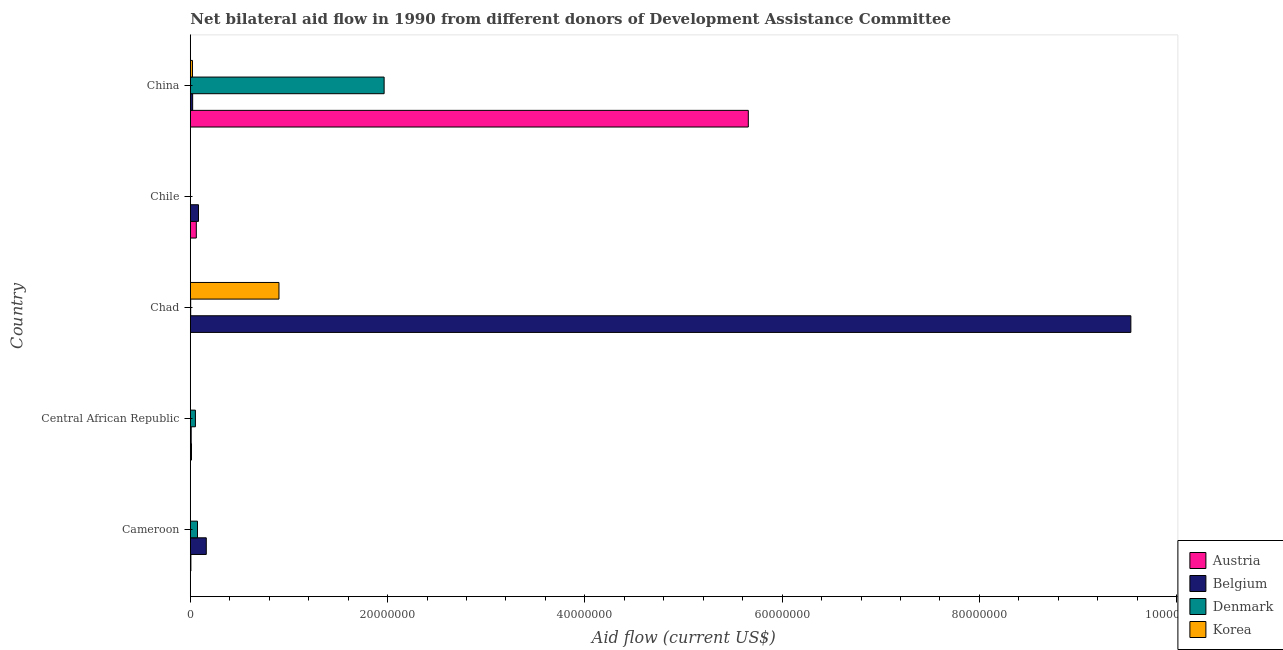How many different coloured bars are there?
Provide a short and direct response. 4. Are the number of bars per tick equal to the number of legend labels?
Keep it short and to the point. No. Are the number of bars on each tick of the Y-axis equal?
Your answer should be compact. No. How many bars are there on the 4th tick from the bottom?
Offer a very short reply. 3. What is the amount of aid given by denmark in Chile?
Your response must be concise. 0. Across all countries, what is the maximum amount of aid given by austria?
Your response must be concise. 5.66e+07. What is the total amount of aid given by korea in the graph?
Offer a very short reply. 9.26e+06. What is the difference between the amount of aid given by korea in Cameroon and that in China?
Offer a terse response. -2.00e+05. What is the difference between the amount of aid given by denmark in Central African Republic and the amount of aid given by korea in Chile?
Your answer should be compact. 5.10e+05. What is the average amount of aid given by denmark per country?
Your response must be concise. 4.19e+06. What is the difference between the amount of aid given by austria and amount of aid given by belgium in Central African Republic?
Ensure brevity in your answer.  3.00e+04. What is the ratio of the amount of aid given by korea in Cameroon to that in Chile?
Offer a terse response. 2. What is the difference between the highest and the second highest amount of aid given by korea?
Offer a terse response. 8.77e+06. What is the difference between the highest and the lowest amount of aid given by austria?
Your answer should be compact. 5.66e+07. How many bars are there?
Your response must be concise. 19. Are all the bars in the graph horizontal?
Provide a succinct answer. Yes. Are the values on the major ticks of X-axis written in scientific E-notation?
Your answer should be very brief. No. Does the graph contain any zero values?
Your answer should be compact. Yes. Does the graph contain grids?
Make the answer very short. No. What is the title of the graph?
Keep it short and to the point. Net bilateral aid flow in 1990 from different donors of Development Assistance Committee. Does "European Union" appear as one of the legend labels in the graph?
Your answer should be compact. No. What is the Aid flow (current US$) of Belgium in Cameroon?
Ensure brevity in your answer.  1.62e+06. What is the Aid flow (current US$) in Denmark in Cameroon?
Give a very brief answer. 7.30e+05. What is the Aid flow (current US$) of Korea in Cameroon?
Offer a very short reply. 2.00e+04. What is the Aid flow (current US$) in Denmark in Central African Republic?
Provide a succinct answer. 5.20e+05. What is the Aid flow (current US$) of Korea in Central African Republic?
Give a very brief answer. 2.00e+04. What is the Aid flow (current US$) of Austria in Chad?
Offer a very short reply. 10000. What is the Aid flow (current US$) in Belgium in Chad?
Your response must be concise. 9.54e+07. What is the Aid flow (current US$) in Korea in Chad?
Provide a short and direct response. 8.99e+06. What is the Aid flow (current US$) in Belgium in Chile?
Provide a short and direct response. 8.30e+05. What is the Aid flow (current US$) of Austria in China?
Keep it short and to the point. 5.66e+07. What is the Aid flow (current US$) of Denmark in China?
Your response must be concise. 1.96e+07. What is the Aid flow (current US$) of Korea in China?
Offer a very short reply. 2.20e+05. Across all countries, what is the maximum Aid flow (current US$) of Austria?
Offer a terse response. 5.66e+07. Across all countries, what is the maximum Aid flow (current US$) in Belgium?
Ensure brevity in your answer.  9.54e+07. Across all countries, what is the maximum Aid flow (current US$) in Denmark?
Provide a succinct answer. 1.96e+07. Across all countries, what is the maximum Aid flow (current US$) in Korea?
Your answer should be compact. 8.99e+06. Across all countries, what is the minimum Aid flow (current US$) of Austria?
Provide a short and direct response. 10000. Across all countries, what is the minimum Aid flow (current US$) in Belgium?
Ensure brevity in your answer.  9.00e+04. Across all countries, what is the minimum Aid flow (current US$) of Denmark?
Your answer should be very brief. 0. Across all countries, what is the minimum Aid flow (current US$) in Korea?
Ensure brevity in your answer.  10000. What is the total Aid flow (current US$) in Austria in the graph?
Provide a succinct answer. 5.74e+07. What is the total Aid flow (current US$) of Belgium in the graph?
Your response must be concise. 9.81e+07. What is the total Aid flow (current US$) of Denmark in the graph?
Your response must be concise. 2.09e+07. What is the total Aid flow (current US$) in Korea in the graph?
Keep it short and to the point. 9.26e+06. What is the difference between the Aid flow (current US$) of Belgium in Cameroon and that in Central African Republic?
Your answer should be compact. 1.53e+06. What is the difference between the Aid flow (current US$) of Belgium in Cameroon and that in Chad?
Provide a short and direct response. -9.37e+07. What is the difference between the Aid flow (current US$) in Denmark in Cameroon and that in Chad?
Provide a short and direct response. 6.90e+05. What is the difference between the Aid flow (current US$) in Korea in Cameroon and that in Chad?
Provide a succinct answer. -8.97e+06. What is the difference between the Aid flow (current US$) in Austria in Cameroon and that in Chile?
Your response must be concise. -5.50e+05. What is the difference between the Aid flow (current US$) in Belgium in Cameroon and that in Chile?
Make the answer very short. 7.90e+05. What is the difference between the Aid flow (current US$) in Korea in Cameroon and that in Chile?
Offer a terse response. 10000. What is the difference between the Aid flow (current US$) in Austria in Cameroon and that in China?
Provide a succinct answer. -5.65e+07. What is the difference between the Aid flow (current US$) of Belgium in Cameroon and that in China?
Make the answer very short. 1.38e+06. What is the difference between the Aid flow (current US$) in Denmark in Cameroon and that in China?
Keep it short and to the point. -1.89e+07. What is the difference between the Aid flow (current US$) in Korea in Cameroon and that in China?
Your answer should be very brief. -2.00e+05. What is the difference between the Aid flow (current US$) of Austria in Central African Republic and that in Chad?
Offer a very short reply. 1.10e+05. What is the difference between the Aid flow (current US$) in Belgium in Central African Republic and that in Chad?
Offer a terse response. -9.53e+07. What is the difference between the Aid flow (current US$) of Korea in Central African Republic and that in Chad?
Provide a succinct answer. -8.97e+06. What is the difference between the Aid flow (current US$) of Austria in Central African Republic and that in Chile?
Offer a terse response. -4.90e+05. What is the difference between the Aid flow (current US$) in Belgium in Central African Republic and that in Chile?
Keep it short and to the point. -7.40e+05. What is the difference between the Aid flow (current US$) of Korea in Central African Republic and that in Chile?
Offer a very short reply. 10000. What is the difference between the Aid flow (current US$) in Austria in Central African Republic and that in China?
Offer a very short reply. -5.64e+07. What is the difference between the Aid flow (current US$) of Belgium in Central African Republic and that in China?
Your answer should be compact. -1.50e+05. What is the difference between the Aid flow (current US$) of Denmark in Central African Republic and that in China?
Offer a very short reply. -1.91e+07. What is the difference between the Aid flow (current US$) in Korea in Central African Republic and that in China?
Offer a terse response. -2.00e+05. What is the difference between the Aid flow (current US$) in Austria in Chad and that in Chile?
Your response must be concise. -6.00e+05. What is the difference between the Aid flow (current US$) in Belgium in Chad and that in Chile?
Keep it short and to the point. 9.45e+07. What is the difference between the Aid flow (current US$) in Korea in Chad and that in Chile?
Provide a succinct answer. 8.98e+06. What is the difference between the Aid flow (current US$) of Austria in Chad and that in China?
Give a very brief answer. -5.66e+07. What is the difference between the Aid flow (current US$) in Belgium in Chad and that in China?
Offer a very short reply. 9.51e+07. What is the difference between the Aid flow (current US$) in Denmark in Chad and that in China?
Your response must be concise. -1.96e+07. What is the difference between the Aid flow (current US$) of Korea in Chad and that in China?
Ensure brevity in your answer.  8.77e+06. What is the difference between the Aid flow (current US$) of Austria in Chile and that in China?
Provide a short and direct response. -5.60e+07. What is the difference between the Aid flow (current US$) of Belgium in Chile and that in China?
Provide a succinct answer. 5.90e+05. What is the difference between the Aid flow (current US$) in Korea in Chile and that in China?
Your answer should be compact. -2.10e+05. What is the difference between the Aid flow (current US$) of Austria in Cameroon and the Aid flow (current US$) of Belgium in Central African Republic?
Offer a terse response. -3.00e+04. What is the difference between the Aid flow (current US$) of Austria in Cameroon and the Aid flow (current US$) of Denmark in Central African Republic?
Provide a short and direct response. -4.60e+05. What is the difference between the Aid flow (current US$) in Austria in Cameroon and the Aid flow (current US$) in Korea in Central African Republic?
Ensure brevity in your answer.  4.00e+04. What is the difference between the Aid flow (current US$) in Belgium in Cameroon and the Aid flow (current US$) in Denmark in Central African Republic?
Your answer should be compact. 1.10e+06. What is the difference between the Aid flow (current US$) of Belgium in Cameroon and the Aid flow (current US$) of Korea in Central African Republic?
Provide a short and direct response. 1.60e+06. What is the difference between the Aid flow (current US$) in Denmark in Cameroon and the Aid flow (current US$) in Korea in Central African Republic?
Your answer should be compact. 7.10e+05. What is the difference between the Aid flow (current US$) in Austria in Cameroon and the Aid flow (current US$) in Belgium in Chad?
Offer a terse response. -9.53e+07. What is the difference between the Aid flow (current US$) of Austria in Cameroon and the Aid flow (current US$) of Denmark in Chad?
Make the answer very short. 2.00e+04. What is the difference between the Aid flow (current US$) in Austria in Cameroon and the Aid flow (current US$) in Korea in Chad?
Offer a very short reply. -8.93e+06. What is the difference between the Aid flow (current US$) of Belgium in Cameroon and the Aid flow (current US$) of Denmark in Chad?
Keep it short and to the point. 1.58e+06. What is the difference between the Aid flow (current US$) of Belgium in Cameroon and the Aid flow (current US$) of Korea in Chad?
Your answer should be very brief. -7.37e+06. What is the difference between the Aid flow (current US$) in Denmark in Cameroon and the Aid flow (current US$) in Korea in Chad?
Your response must be concise. -8.26e+06. What is the difference between the Aid flow (current US$) of Austria in Cameroon and the Aid flow (current US$) of Belgium in Chile?
Keep it short and to the point. -7.70e+05. What is the difference between the Aid flow (current US$) in Austria in Cameroon and the Aid flow (current US$) in Korea in Chile?
Your answer should be very brief. 5.00e+04. What is the difference between the Aid flow (current US$) of Belgium in Cameroon and the Aid flow (current US$) of Korea in Chile?
Offer a terse response. 1.61e+06. What is the difference between the Aid flow (current US$) in Denmark in Cameroon and the Aid flow (current US$) in Korea in Chile?
Your response must be concise. 7.20e+05. What is the difference between the Aid flow (current US$) of Austria in Cameroon and the Aid flow (current US$) of Denmark in China?
Make the answer very short. -1.96e+07. What is the difference between the Aid flow (current US$) in Belgium in Cameroon and the Aid flow (current US$) in Denmark in China?
Your answer should be very brief. -1.80e+07. What is the difference between the Aid flow (current US$) in Belgium in Cameroon and the Aid flow (current US$) in Korea in China?
Provide a succinct answer. 1.40e+06. What is the difference between the Aid flow (current US$) in Denmark in Cameroon and the Aid flow (current US$) in Korea in China?
Give a very brief answer. 5.10e+05. What is the difference between the Aid flow (current US$) of Austria in Central African Republic and the Aid flow (current US$) of Belgium in Chad?
Your answer should be compact. -9.52e+07. What is the difference between the Aid flow (current US$) in Austria in Central African Republic and the Aid flow (current US$) in Denmark in Chad?
Provide a succinct answer. 8.00e+04. What is the difference between the Aid flow (current US$) of Austria in Central African Republic and the Aid flow (current US$) of Korea in Chad?
Ensure brevity in your answer.  -8.87e+06. What is the difference between the Aid flow (current US$) of Belgium in Central African Republic and the Aid flow (current US$) of Denmark in Chad?
Your response must be concise. 5.00e+04. What is the difference between the Aid flow (current US$) of Belgium in Central African Republic and the Aid flow (current US$) of Korea in Chad?
Your response must be concise. -8.90e+06. What is the difference between the Aid flow (current US$) in Denmark in Central African Republic and the Aid flow (current US$) in Korea in Chad?
Give a very brief answer. -8.47e+06. What is the difference between the Aid flow (current US$) in Austria in Central African Republic and the Aid flow (current US$) in Belgium in Chile?
Make the answer very short. -7.10e+05. What is the difference between the Aid flow (current US$) of Belgium in Central African Republic and the Aid flow (current US$) of Korea in Chile?
Make the answer very short. 8.00e+04. What is the difference between the Aid flow (current US$) of Denmark in Central African Republic and the Aid flow (current US$) of Korea in Chile?
Provide a succinct answer. 5.10e+05. What is the difference between the Aid flow (current US$) in Austria in Central African Republic and the Aid flow (current US$) in Belgium in China?
Offer a terse response. -1.20e+05. What is the difference between the Aid flow (current US$) of Austria in Central African Republic and the Aid flow (current US$) of Denmark in China?
Your response must be concise. -1.95e+07. What is the difference between the Aid flow (current US$) in Belgium in Central African Republic and the Aid flow (current US$) in Denmark in China?
Give a very brief answer. -1.96e+07. What is the difference between the Aid flow (current US$) in Austria in Chad and the Aid flow (current US$) in Belgium in Chile?
Offer a terse response. -8.20e+05. What is the difference between the Aid flow (current US$) in Belgium in Chad and the Aid flow (current US$) in Korea in Chile?
Provide a short and direct response. 9.53e+07. What is the difference between the Aid flow (current US$) of Denmark in Chad and the Aid flow (current US$) of Korea in Chile?
Offer a terse response. 3.00e+04. What is the difference between the Aid flow (current US$) in Austria in Chad and the Aid flow (current US$) in Denmark in China?
Provide a succinct answer. -1.96e+07. What is the difference between the Aid flow (current US$) of Belgium in Chad and the Aid flow (current US$) of Denmark in China?
Make the answer very short. 7.57e+07. What is the difference between the Aid flow (current US$) in Belgium in Chad and the Aid flow (current US$) in Korea in China?
Offer a very short reply. 9.51e+07. What is the difference between the Aid flow (current US$) of Denmark in Chad and the Aid flow (current US$) of Korea in China?
Make the answer very short. -1.80e+05. What is the difference between the Aid flow (current US$) of Austria in Chile and the Aid flow (current US$) of Belgium in China?
Your response must be concise. 3.70e+05. What is the difference between the Aid flow (current US$) of Austria in Chile and the Aid flow (current US$) of Denmark in China?
Keep it short and to the point. -1.90e+07. What is the difference between the Aid flow (current US$) in Austria in Chile and the Aid flow (current US$) in Korea in China?
Offer a very short reply. 3.90e+05. What is the difference between the Aid flow (current US$) of Belgium in Chile and the Aid flow (current US$) of Denmark in China?
Your answer should be very brief. -1.88e+07. What is the difference between the Aid flow (current US$) of Belgium in Chile and the Aid flow (current US$) of Korea in China?
Give a very brief answer. 6.10e+05. What is the average Aid flow (current US$) in Austria per country?
Ensure brevity in your answer.  1.15e+07. What is the average Aid flow (current US$) of Belgium per country?
Give a very brief answer. 1.96e+07. What is the average Aid flow (current US$) in Denmark per country?
Keep it short and to the point. 4.19e+06. What is the average Aid flow (current US$) in Korea per country?
Offer a terse response. 1.85e+06. What is the difference between the Aid flow (current US$) of Austria and Aid flow (current US$) of Belgium in Cameroon?
Your answer should be very brief. -1.56e+06. What is the difference between the Aid flow (current US$) of Austria and Aid flow (current US$) of Denmark in Cameroon?
Your answer should be compact. -6.70e+05. What is the difference between the Aid flow (current US$) of Belgium and Aid flow (current US$) of Denmark in Cameroon?
Your answer should be very brief. 8.90e+05. What is the difference between the Aid flow (current US$) in Belgium and Aid flow (current US$) in Korea in Cameroon?
Your response must be concise. 1.60e+06. What is the difference between the Aid flow (current US$) of Denmark and Aid flow (current US$) of Korea in Cameroon?
Your answer should be very brief. 7.10e+05. What is the difference between the Aid flow (current US$) in Austria and Aid flow (current US$) in Belgium in Central African Republic?
Make the answer very short. 3.00e+04. What is the difference between the Aid flow (current US$) in Austria and Aid flow (current US$) in Denmark in Central African Republic?
Ensure brevity in your answer.  -4.00e+05. What is the difference between the Aid flow (current US$) of Belgium and Aid flow (current US$) of Denmark in Central African Republic?
Offer a very short reply. -4.30e+05. What is the difference between the Aid flow (current US$) of Austria and Aid flow (current US$) of Belgium in Chad?
Ensure brevity in your answer.  -9.53e+07. What is the difference between the Aid flow (current US$) of Austria and Aid flow (current US$) of Denmark in Chad?
Your answer should be compact. -3.00e+04. What is the difference between the Aid flow (current US$) of Austria and Aid flow (current US$) of Korea in Chad?
Your response must be concise. -8.98e+06. What is the difference between the Aid flow (current US$) in Belgium and Aid flow (current US$) in Denmark in Chad?
Offer a very short reply. 9.53e+07. What is the difference between the Aid flow (current US$) in Belgium and Aid flow (current US$) in Korea in Chad?
Your response must be concise. 8.64e+07. What is the difference between the Aid flow (current US$) in Denmark and Aid flow (current US$) in Korea in Chad?
Your response must be concise. -8.95e+06. What is the difference between the Aid flow (current US$) in Belgium and Aid flow (current US$) in Korea in Chile?
Offer a very short reply. 8.20e+05. What is the difference between the Aid flow (current US$) in Austria and Aid flow (current US$) in Belgium in China?
Make the answer very short. 5.63e+07. What is the difference between the Aid flow (current US$) in Austria and Aid flow (current US$) in Denmark in China?
Your response must be concise. 3.69e+07. What is the difference between the Aid flow (current US$) of Austria and Aid flow (current US$) of Korea in China?
Provide a short and direct response. 5.64e+07. What is the difference between the Aid flow (current US$) of Belgium and Aid flow (current US$) of Denmark in China?
Provide a succinct answer. -1.94e+07. What is the difference between the Aid flow (current US$) of Denmark and Aid flow (current US$) of Korea in China?
Offer a terse response. 1.94e+07. What is the ratio of the Aid flow (current US$) of Austria in Cameroon to that in Central African Republic?
Provide a succinct answer. 0.5. What is the ratio of the Aid flow (current US$) in Denmark in Cameroon to that in Central African Republic?
Offer a terse response. 1.4. What is the ratio of the Aid flow (current US$) in Austria in Cameroon to that in Chad?
Give a very brief answer. 6. What is the ratio of the Aid flow (current US$) of Belgium in Cameroon to that in Chad?
Make the answer very short. 0.02. What is the ratio of the Aid flow (current US$) of Denmark in Cameroon to that in Chad?
Offer a terse response. 18.25. What is the ratio of the Aid flow (current US$) of Korea in Cameroon to that in Chad?
Your answer should be compact. 0. What is the ratio of the Aid flow (current US$) in Austria in Cameroon to that in Chile?
Your answer should be compact. 0.1. What is the ratio of the Aid flow (current US$) of Belgium in Cameroon to that in Chile?
Keep it short and to the point. 1.95. What is the ratio of the Aid flow (current US$) of Korea in Cameroon to that in Chile?
Your answer should be compact. 2. What is the ratio of the Aid flow (current US$) in Austria in Cameroon to that in China?
Provide a short and direct response. 0. What is the ratio of the Aid flow (current US$) in Belgium in Cameroon to that in China?
Keep it short and to the point. 6.75. What is the ratio of the Aid flow (current US$) of Denmark in Cameroon to that in China?
Your answer should be compact. 0.04. What is the ratio of the Aid flow (current US$) in Korea in Cameroon to that in China?
Your answer should be very brief. 0.09. What is the ratio of the Aid flow (current US$) in Austria in Central African Republic to that in Chad?
Keep it short and to the point. 12. What is the ratio of the Aid flow (current US$) of Belgium in Central African Republic to that in Chad?
Your response must be concise. 0. What is the ratio of the Aid flow (current US$) in Denmark in Central African Republic to that in Chad?
Offer a terse response. 13. What is the ratio of the Aid flow (current US$) of Korea in Central African Republic to that in Chad?
Your answer should be compact. 0. What is the ratio of the Aid flow (current US$) of Austria in Central African Republic to that in Chile?
Ensure brevity in your answer.  0.2. What is the ratio of the Aid flow (current US$) of Belgium in Central African Republic to that in Chile?
Your answer should be compact. 0.11. What is the ratio of the Aid flow (current US$) in Korea in Central African Republic to that in Chile?
Your response must be concise. 2. What is the ratio of the Aid flow (current US$) of Austria in Central African Republic to that in China?
Make the answer very short. 0. What is the ratio of the Aid flow (current US$) of Denmark in Central African Republic to that in China?
Your response must be concise. 0.03. What is the ratio of the Aid flow (current US$) in Korea in Central African Republic to that in China?
Your answer should be compact. 0.09. What is the ratio of the Aid flow (current US$) of Austria in Chad to that in Chile?
Offer a terse response. 0.02. What is the ratio of the Aid flow (current US$) in Belgium in Chad to that in Chile?
Make the answer very short. 114.88. What is the ratio of the Aid flow (current US$) in Korea in Chad to that in Chile?
Your answer should be very brief. 899. What is the ratio of the Aid flow (current US$) of Austria in Chad to that in China?
Give a very brief answer. 0. What is the ratio of the Aid flow (current US$) in Belgium in Chad to that in China?
Give a very brief answer. 397.29. What is the ratio of the Aid flow (current US$) of Denmark in Chad to that in China?
Provide a succinct answer. 0. What is the ratio of the Aid flow (current US$) of Korea in Chad to that in China?
Provide a short and direct response. 40.86. What is the ratio of the Aid flow (current US$) in Austria in Chile to that in China?
Offer a terse response. 0.01. What is the ratio of the Aid flow (current US$) of Belgium in Chile to that in China?
Keep it short and to the point. 3.46. What is the ratio of the Aid flow (current US$) in Korea in Chile to that in China?
Give a very brief answer. 0.05. What is the difference between the highest and the second highest Aid flow (current US$) of Austria?
Your answer should be compact. 5.60e+07. What is the difference between the highest and the second highest Aid flow (current US$) of Belgium?
Offer a very short reply. 9.37e+07. What is the difference between the highest and the second highest Aid flow (current US$) in Denmark?
Offer a terse response. 1.89e+07. What is the difference between the highest and the second highest Aid flow (current US$) in Korea?
Your answer should be compact. 8.77e+06. What is the difference between the highest and the lowest Aid flow (current US$) of Austria?
Ensure brevity in your answer.  5.66e+07. What is the difference between the highest and the lowest Aid flow (current US$) of Belgium?
Offer a very short reply. 9.53e+07. What is the difference between the highest and the lowest Aid flow (current US$) in Denmark?
Your response must be concise. 1.96e+07. What is the difference between the highest and the lowest Aid flow (current US$) of Korea?
Offer a terse response. 8.98e+06. 